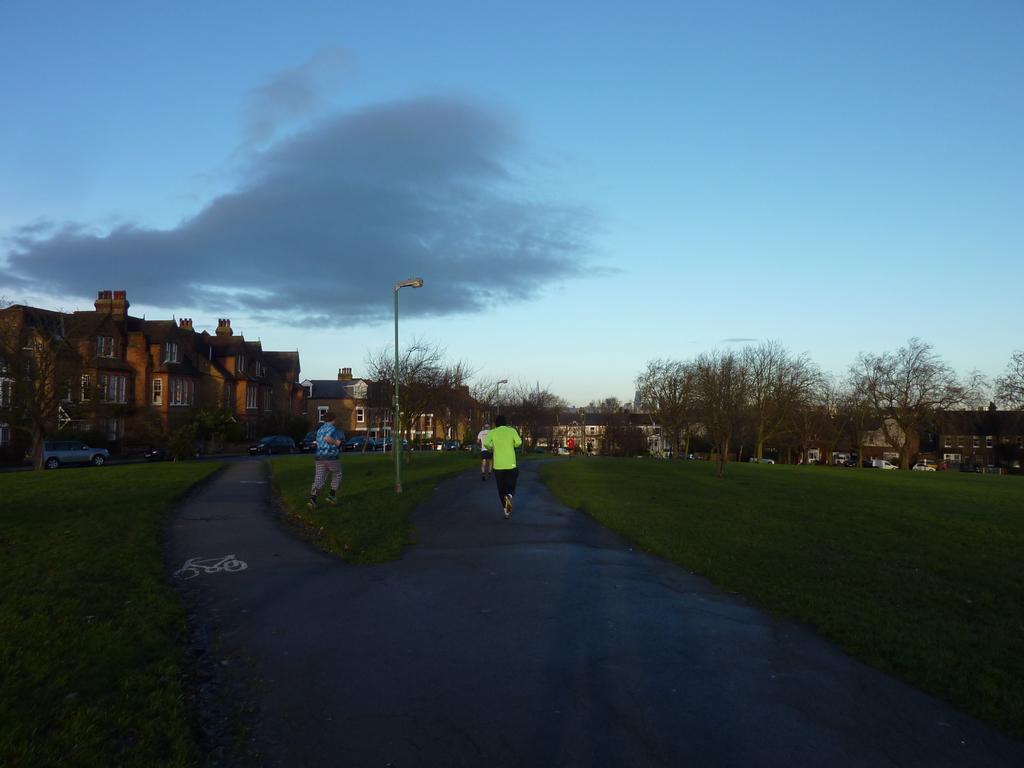Could you give a brief overview of what you see in this image? In the foreground of the picture there are roads, grass, street light and two persons walking. In the center of the picture there are trees, buildings and vehicles. Sky is bit cloudy. 